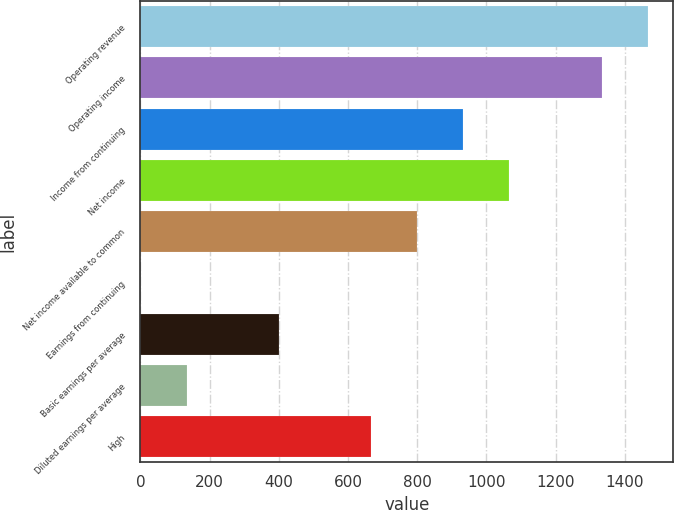Convert chart. <chart><loc_0><loc_0><loc_500><loc_500><bar_chart><fcel>Operating revenue<fcel>Operating income<fcel>Income from continuing<fcel>Net income<fcel>Net income available to common<fcel>Earnings from continuing<fcel>Basic earnings per average<fcel>Diluted earnings per average<fcel>High<nl><fcel>1466.23<fcel>1332.97<fcel>933.19<fcel>1066.45<fcel>799.93<fcel>0.37<fcel>400.15<fcel>133.63<fcel>666.67<nl></chart> 